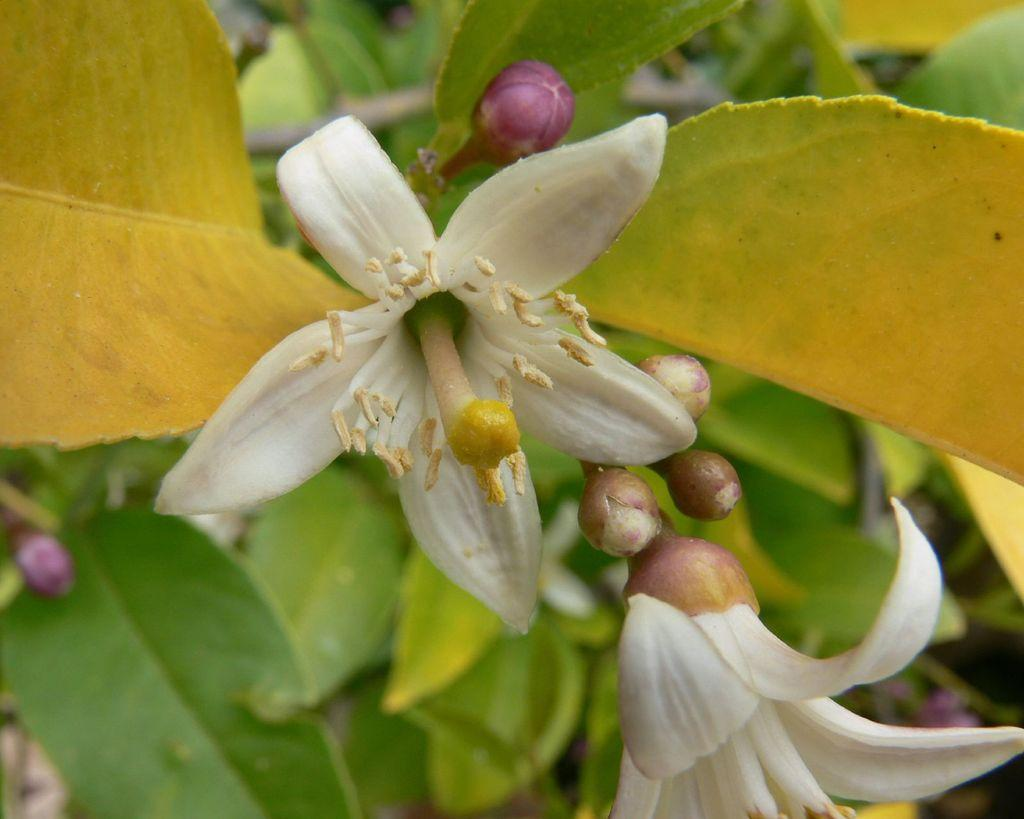What is the main subject of the image? There is a plant with flowers in the center of the image. What is the current stage of the plant's flowers? The plant has flower buds. Can you describe the background of the image? There are plants visible in the background of the image. What type of stick is being used to hold up the flowers in the image? There is no stick or dog present in the image; it features a plant with flowers and flower buds. 